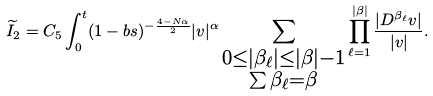<formula> <loc_0><loc_0><loc_500><loc_500>\widetilde { I } _ { 2 } = C _ { 5 } \int _ { 0 } ^ { t } ( 1 - b s ) ^ { - \frac { 4 - N \alpha } { 2 } } | v | ^ { \alpha } \sum _ { \substack { 0 \leq | \beta _ { \ell } | \leq | \beta | - 1 \\ \sum \beta _ { \ell } = \beta } } \prod _ { \ell = 1 } ^ { | \beta | } \frac { | D ^ { \beta _ { \ell } } v | } { | v | } .</formula> 